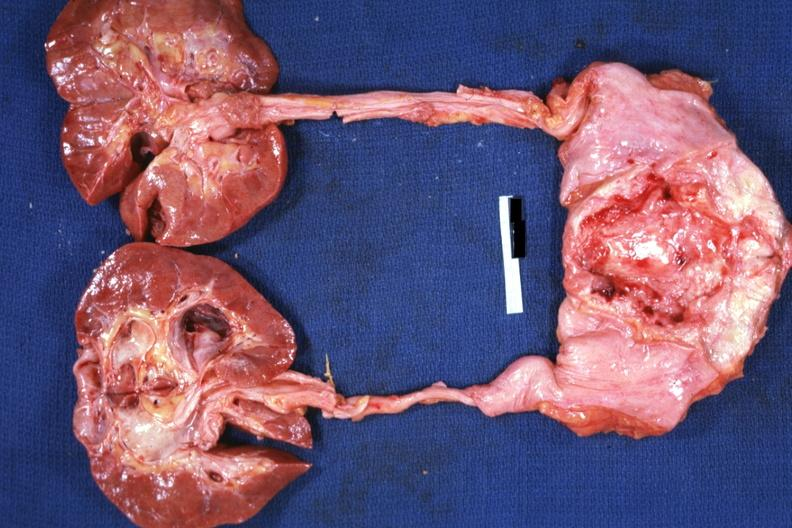what does this image show?
Answer the question using a single word or phrase. View of prostate bladder ureters and kidneys quite good shows prostate tumor invading floor of bladder causing hydroureter and hydronephrosis 